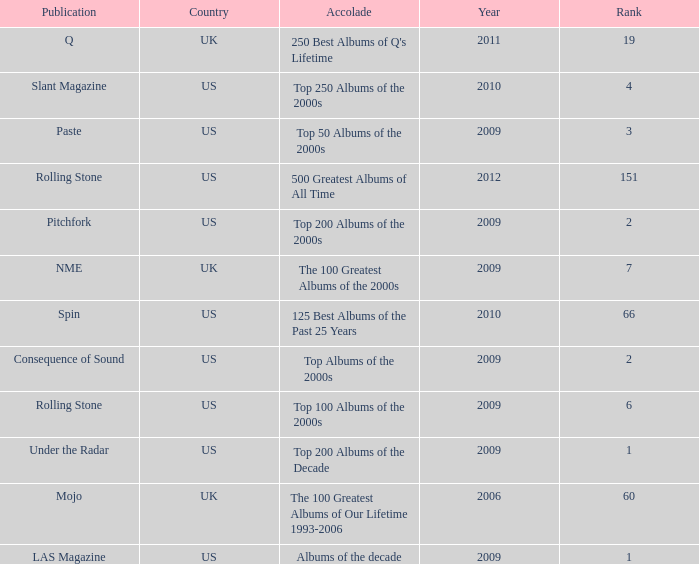What country had a paste publication in 2009? US. 